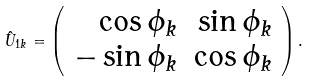Convert formula to latex. <formula><loc_0><loc_0><loc_500><loc_500>\hat { U } _ { 1 k } = \left ( \begin{array} { r r } \cos \phi _ { k } & \sin \phi _ { k } \\ - \sin \phi _ { k } & \cos \phi _ { k } \end{array} \right ) .</formula> 